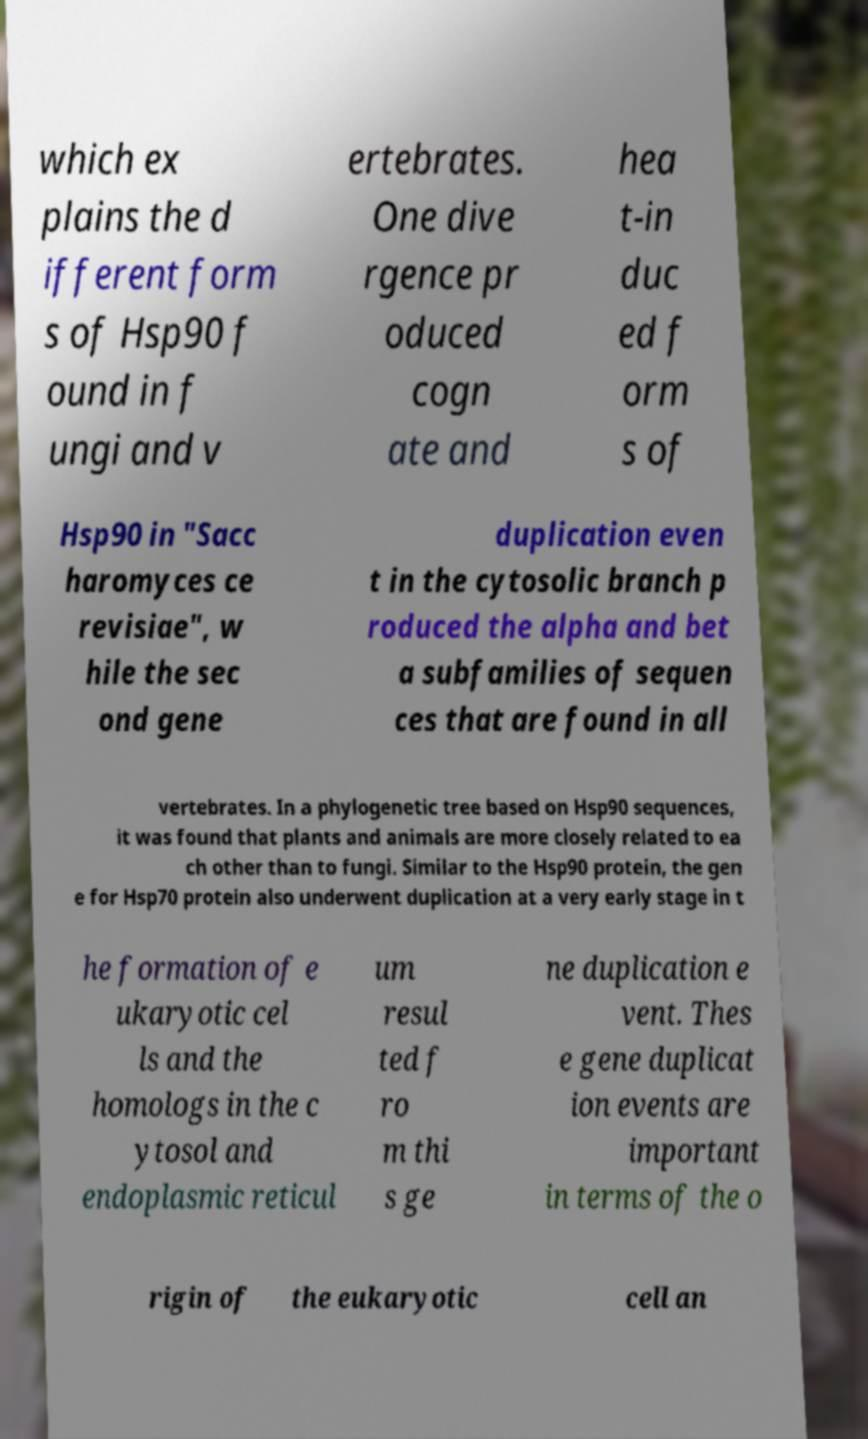Can you read and provide the text displayed in the image?This photo seems to have some interesting text. Can you extract and type it out for me? which ex plains the d ifferent form s of Hsp90 f ound in f ungi and v ertebrates. One dive rgence pr oduced cogn ate and hea t-in duc ed f orm s of Hsp90 in "Sacc haromyces ce revisiae", w hile the sec ond gene duplication even t in the cytosolic branch p roduced the alpha and bet a subfamilies of sequen ces that are found in all vertebrates. In a phylogenetic tree based on Hsp90 sequences, it was found that plants and animals are more closely related to ea ch other than to fungi. Similar to the Hsp90 protein, the gen e for Hsp70 protein also underwent duplication at a very early stage in t he formation of e ukaryotic cel ls and the homologs in the c ytosol and endoplasmic reticul um resul ted f ro m thi s ge ne duplication e vent. Thes e gene duplicat ion events are important in terms of the o rigin of the eukaryotic cell an 